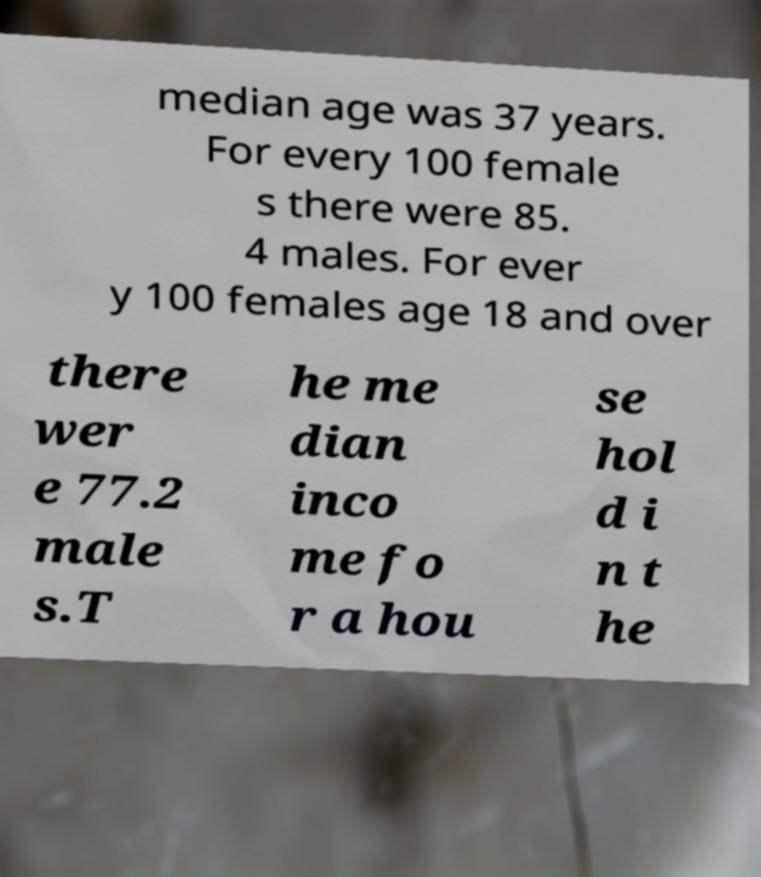Please read and relay the text visible in this image. What does it say? median age was 37 years. For every 100 female s there were 85. 4 males. For ever y 100 females age 18 and over there wer e 77.2 male s.T he me dian inco me fo r a hou se hol d i n t he 